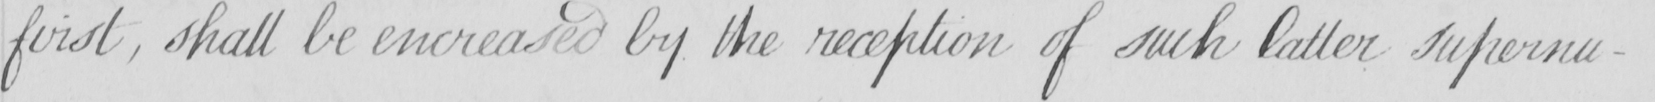What does this handwritten line say? first , shall be encreased by the reception of such latter supernu- 